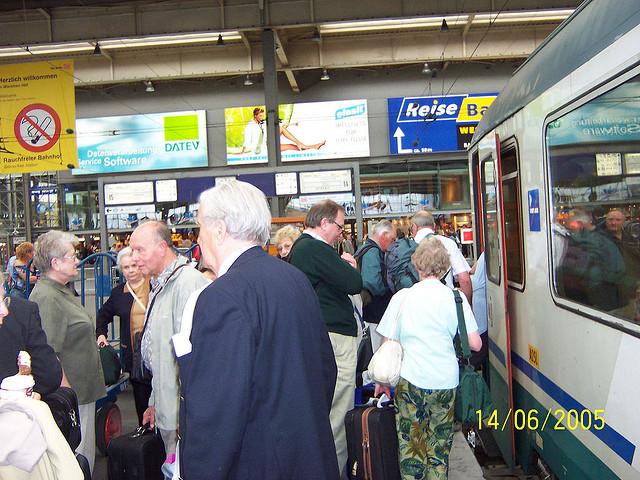What are they waiting on?
Quick response, please. Train. What is the date of the picture?
Keep it brief. 14/06/2005. How many billboards do you see?
Quick response, please. 3. 